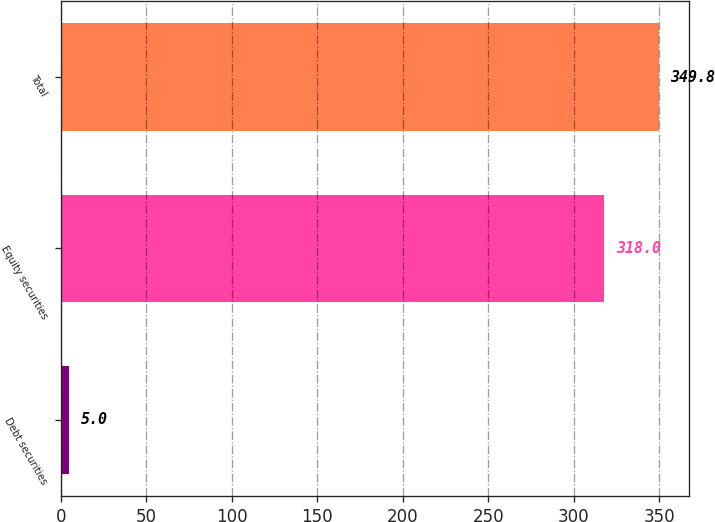Convert chart to OTSL. <chart><loc_0><loc_0><loc_500><loc_500><bar_chart><fcel>Debt securities<fcel>Equity securities<fcel>Total<nl><fcel>5<fcel>318<fcel>349.8<nl></chart> 